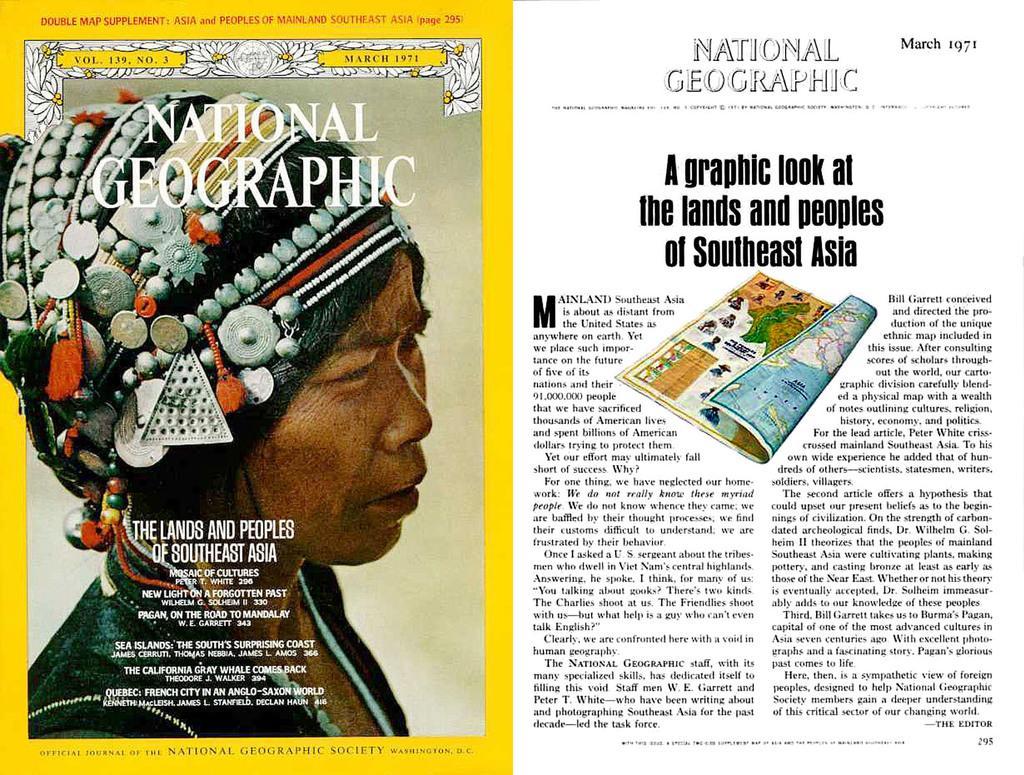How would you summarize this image in a sentence or two? In the image we can see there is a newspaper clipping and in front there is a picture of a woman. Beside there is a matter and its written ¨Graphics Look At The Lions And Peoples Of Southeast Asia¨ on the top its written ¨National Geographic¨. 